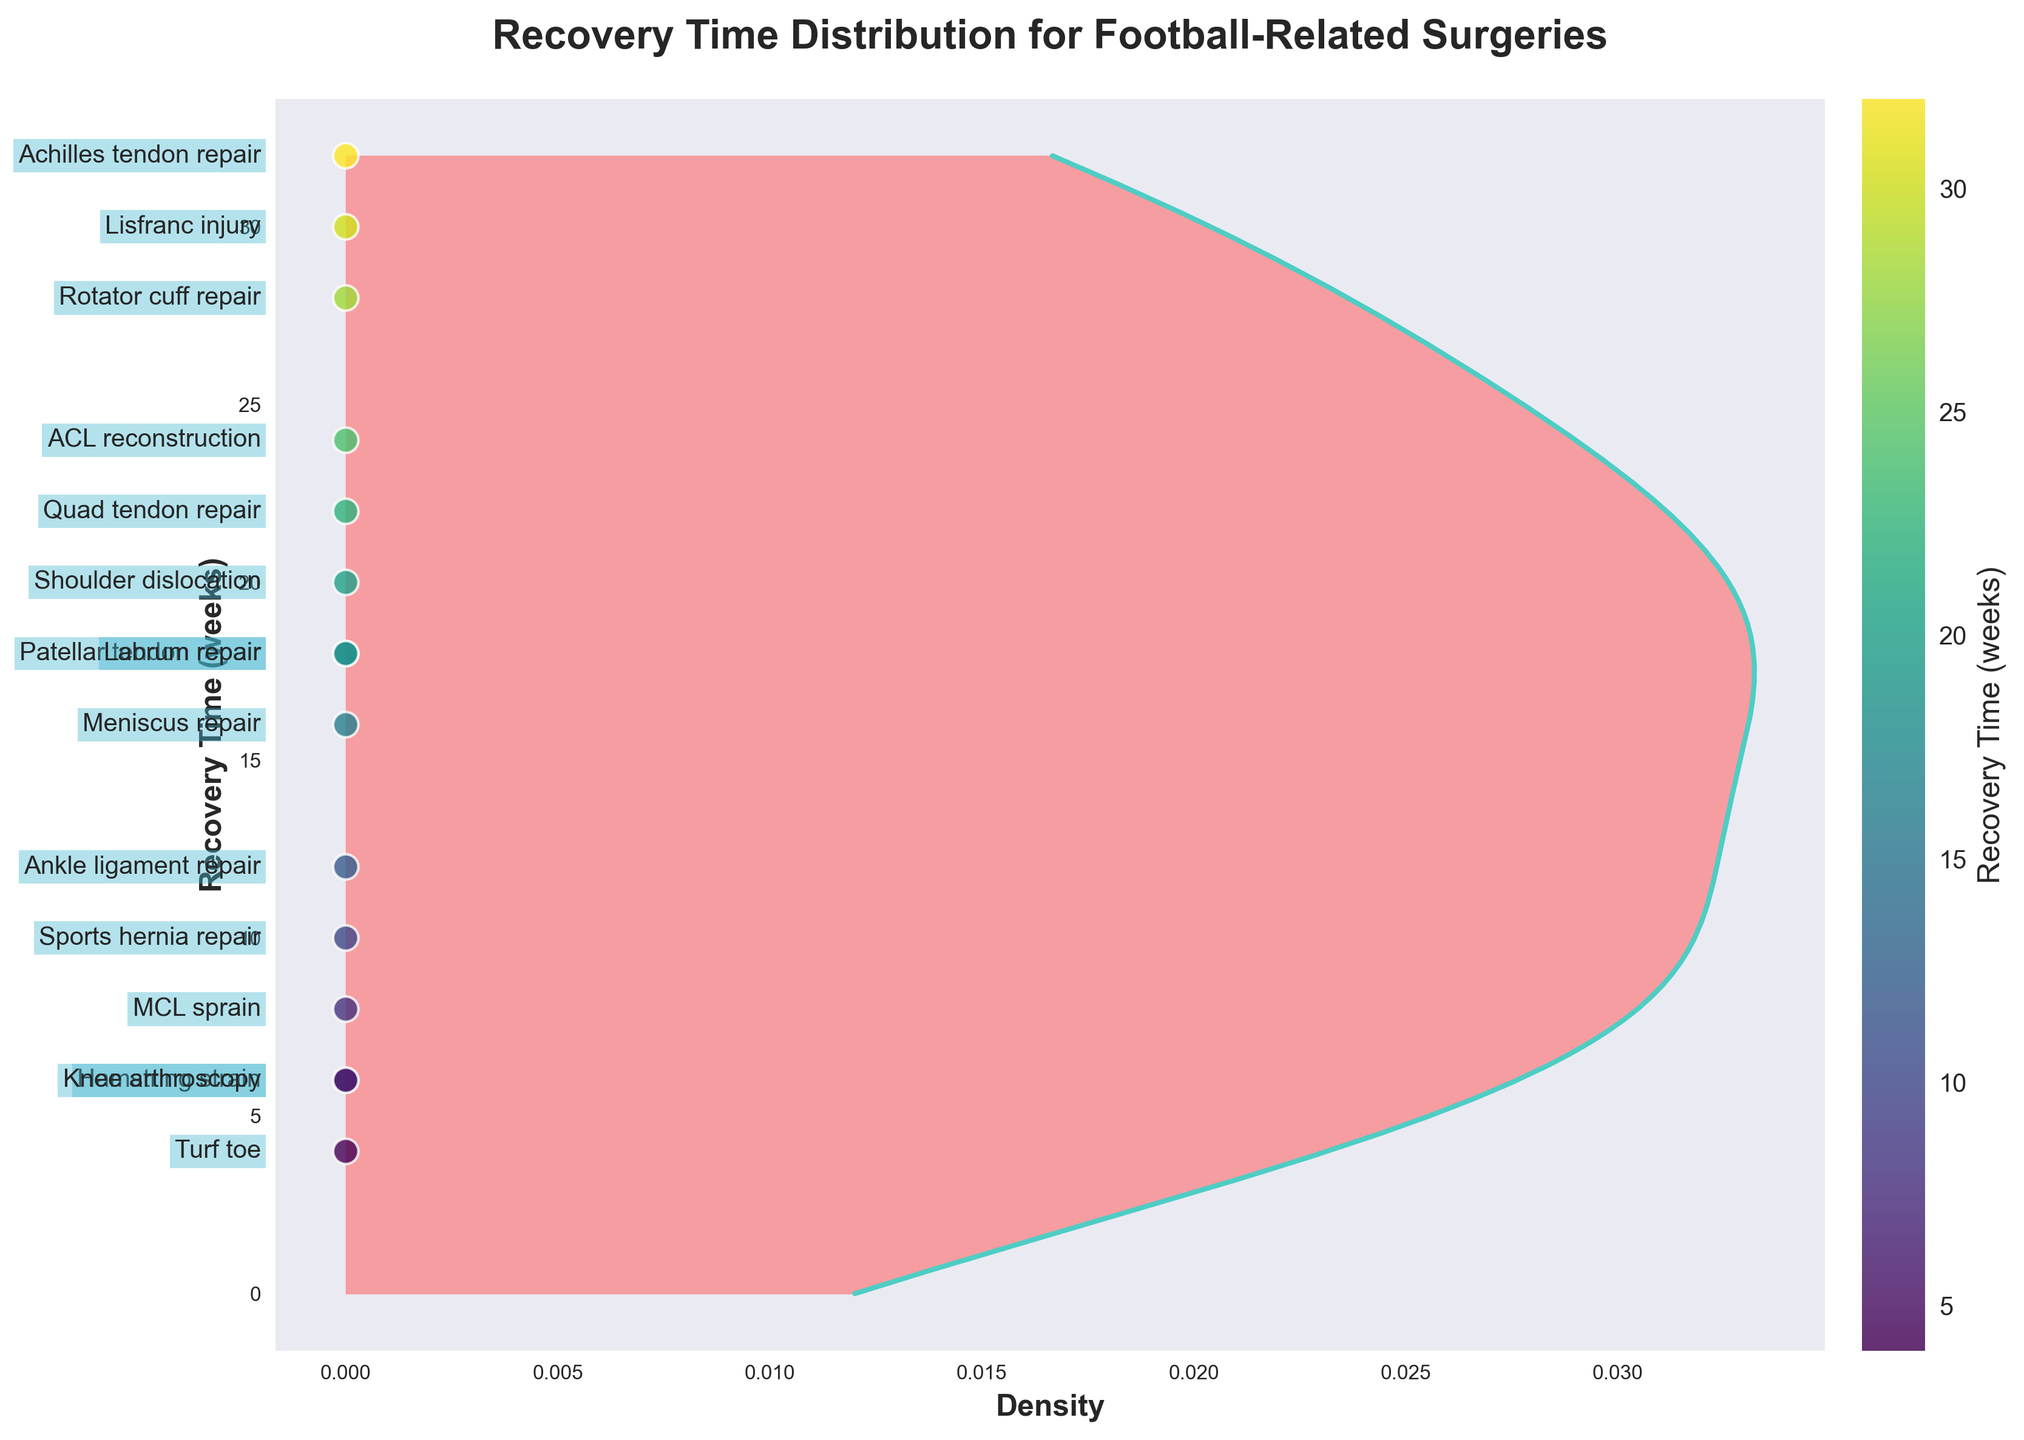Which surgery has the quickest recovery time? The scatter plot shows individual recovery times for different surgeries, and the shortest recovery time can be identified by the lowest positioned scatter point.
Answer: Turf toe What’s the title of the figure? The title is displayed at the top center of the plot and provides a brief description of the graph's contents.
Answer: Recovery Time Distribution for Football-Related Surgeries Which surgery has the longest recovery time? The longest recovery time can be found by looking for the highest positioned scatter point on the plot.
Answer: Achilles tendon repair What is the average recovery time for the listed surgeries? The average can be calculated by summing all the recovery times and dividing by the number of surgeries. The recovery times given are 24, 16, 12, 20, 32, 28, 8, 6, 10, 6, 18, 22, 18, 30, 4. Their sum is 254, and there are 15 surgeries. 254 / 15 = 16.93 weeks.
Answer: 16.93 weeks What’s the color used for the density fill on the plot? The fill color of the density plot is clearly visible and predominant in the plot area.
Answer: Light red (#FF6B6B) How many surgeries have a recovery time of 10 weeks or less? Surgeries with recovery times of 10 weeks or less can be identified on the scatter plot as points positioned at or below the 10-week mark. Surgeries identified are 8 + 6 + 6 + 10 + 4, which totals 5 surgeries.
Answer: 5 surgeries Which surgery takes longer to recover from: MCL sprain or Labrum repair? The scatter plot shows individual recovery times, allowing a comparison between the positions of the points labeled 'MCL sprain' and 'Labrum repair'.
Answer: Labrum repair What is the range of recovery times displayed in the plot? The range is determined by the difference between the maximum and minimum recovery times. The maximum is 32 weeks and the minimum is 4 weeks. The range is 32 - 4 = 28 weeks.
Answer: 28 weeks What color represents recovery time in the scatter plot? The scatter plot points are color-coded, and the color used can be observed directly in the figure.
Answer: Viridis (a gradient scale ranging from purple to yellow in this context) At what recovery time does the density curve peak? The peak of the density curve can be identified by the highest point along the density axis.
Answer: Around 6 weeks 